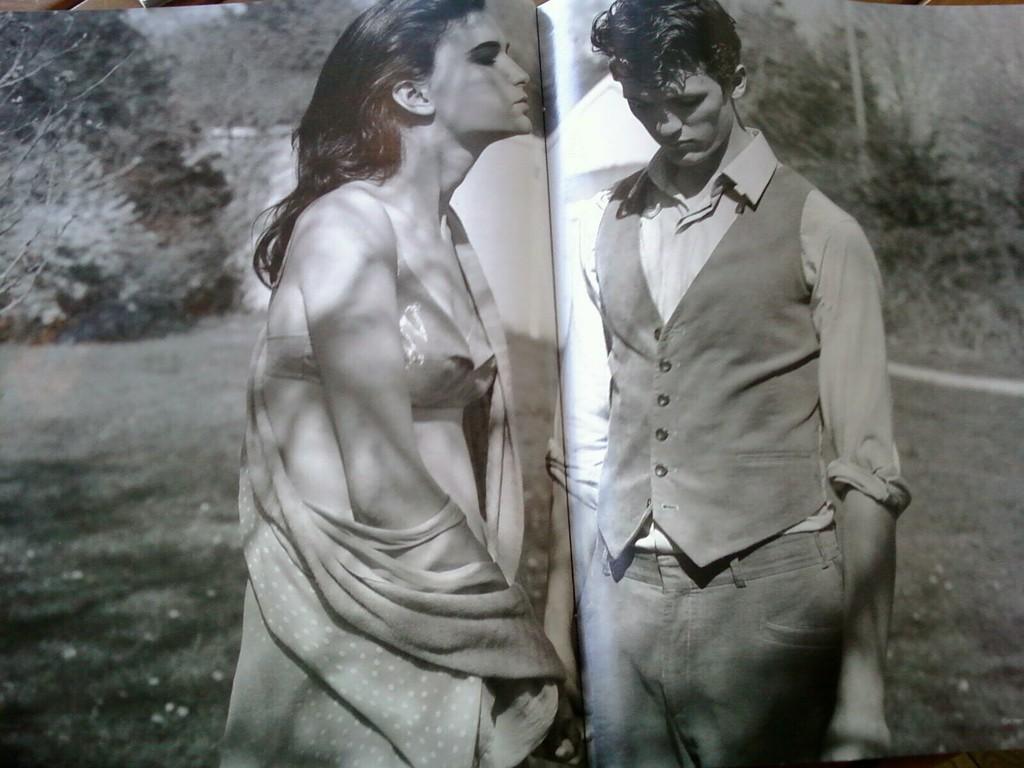Can you describe this image briefly? This image consist of a book. Here I can see a man and a woman are standing. In the background, I can see some trees. This is a black and white image. 